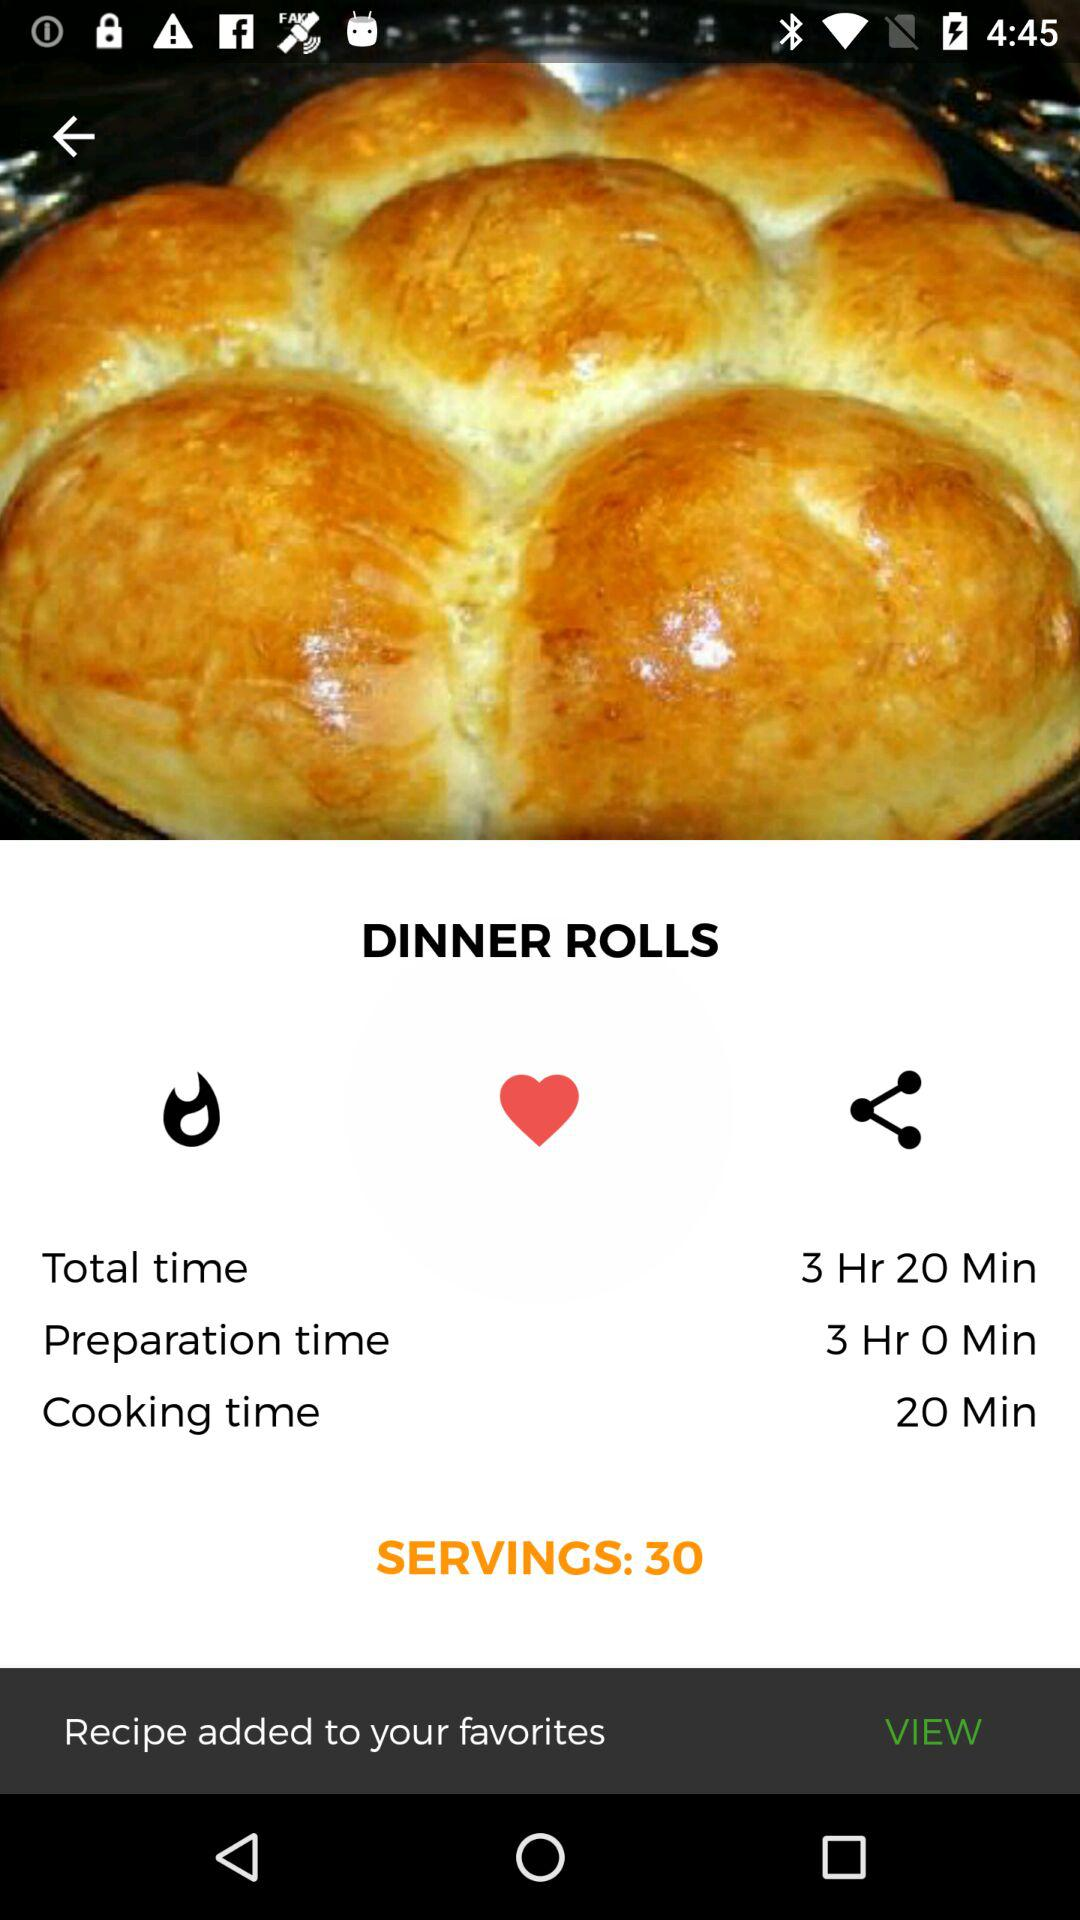What is the cooking time shown? The cooking time is 20 minutes. 